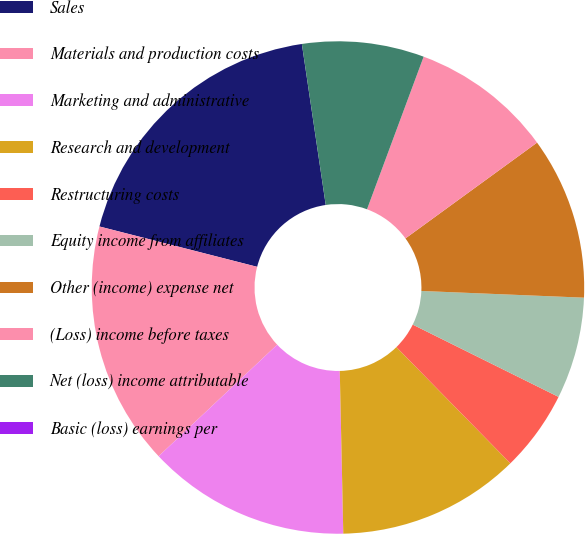Convert chart. <chart><loc_0><loc_0><loc_500><loc_500><pie_chart><fcel>Sales<fcel>Materials and production costs<fcel>Marketing and administrative<fcel>Research and development<fcel>Restructuring costs<fcel>Equity income from affiliates<fcel>Other (income) expense net<fcel>(Loss) income before taxes<fcel>Net (loss) income attributable<fcel>Basic (loss) earnings per<nl><fcel>18.67%<fcel>16.0%<fcel>13.33%<fcel>12.0%<fcel>5.33%<fcel>6.67%<fcel>10.67%<fcel>9.33%<fcel>8.0%<fcel>0.0%<nl></chart> 